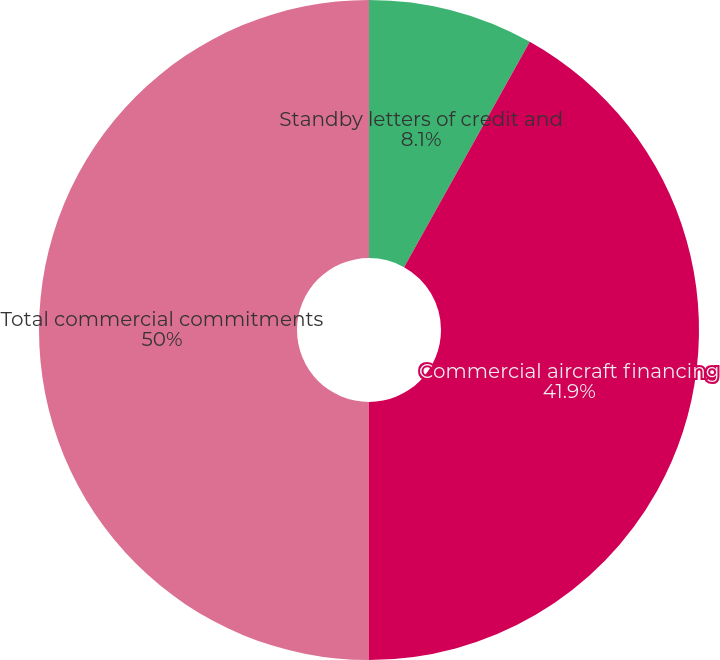Convert chart to OTSL. <chart><loc_0><loc_0><loc_500><loc_500><pie_chart><fcel>Standby letters of credit and<fcel>Commercial aircraft financing<fcel>Total commercial commitments<nl><fcel>8.1%<fcel>41.9%<fcel>50.0%<nl></chart> 